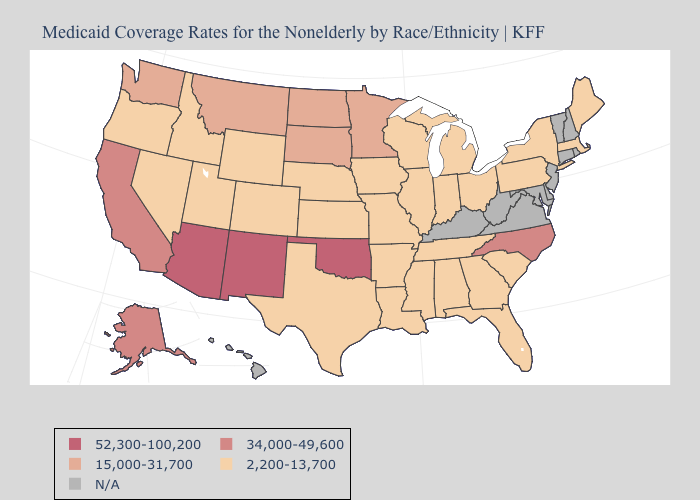How many symbols are there in the legend?
Keep it brief. 5. Among the states that border Georgia , which have the lowest value?
Short answer required. Alabama, Florida, South Carolina, Tennessee. Name the states that have a value in the range 34,000-49,600?
Short answer required. Alaska, California, North Carolina. Does the map have missing data?
Answer briefly. Yes. Does Nebraska have the lowest value in the MidWest?
Be succinct. Yes. What is the highest value in the USA?
Be succinct. 52,300-100,200. Which states hav the highest value in the Northeast?
Give a very brief answer. Maine, Massachusetts, New York, Pennsylvania. Name the states that have a value in the range 15,000-31,700?
Be succinct. Minnesota, Montana, North Dakota, South Dakota, Washington. Does Oregon have the lowest value in the USA?
Answer briefly. Yes. What is the highest value in the MidWest ?
Answer briefly. 15,000-31,700. Among the states that border California , does Arizona have the lowest value?
Be succinct. No. What is the value of Massachusetts?
Quick response, please. 2,200-13,700. Does the map have missing data?
Concise answer only. Yes. Name the states that have a value in the range 2,200-13,700?
Short answer required. Alabama, Arkansas, Colorado, Florida, Georgia, Idaho, Illinois, Indiana, Iowa, Kansas, Louisiana, Maine, Massachusetts, Michigan, Mississippi, Missouri, Nebraska, Nevada, New York, Ohio, Oregon, Pennsylvania, South Carolina, Tennessee, Texas, Utah, Wisconsin, Wyoming. 